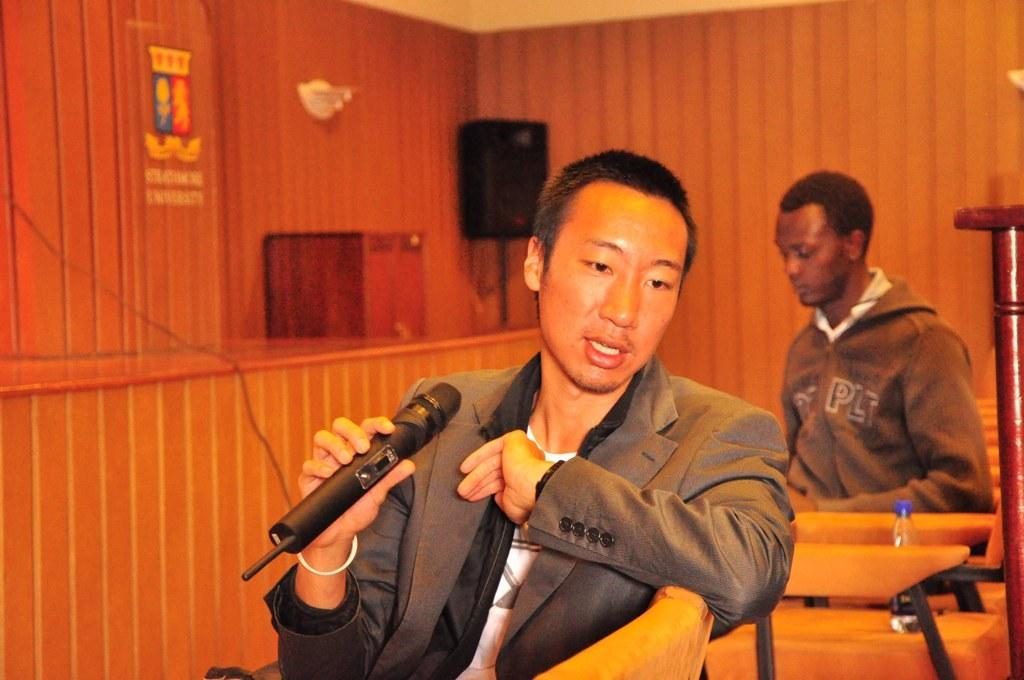What is the person in the image doing? The person is holding a microphone and talking. What can be seen in the background of the image? There is a wall, a speaker, at least one other person, grass, an object, chairs, a bottle, and other unspecified things in the background of the image. What type of knowledge is the person sharing through the oven in the image? There is no oven present in the image, and therefore no knowledge can be shared through it. 